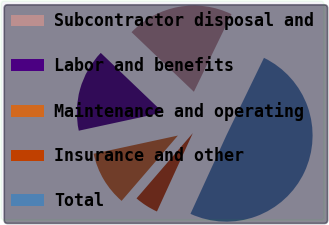<chart> <loc_0><loc_0><loc_500><loc_500><pie_chart><fcel>Subcontractor disposal and<fcel>Labor and benefits<fcel>Maintenance and operating<fcel>Insurance and other<fcel>Total<nl><fcel>20.04%<fcel>15.53%<fcel>10.29%<fcel>4.49%<fcel>49.65%<nl></chart> 